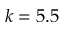Convert formula to latex. <formula><loc_0><loc_0><loc_500><loc_500>k = 5 . 5</formula> 